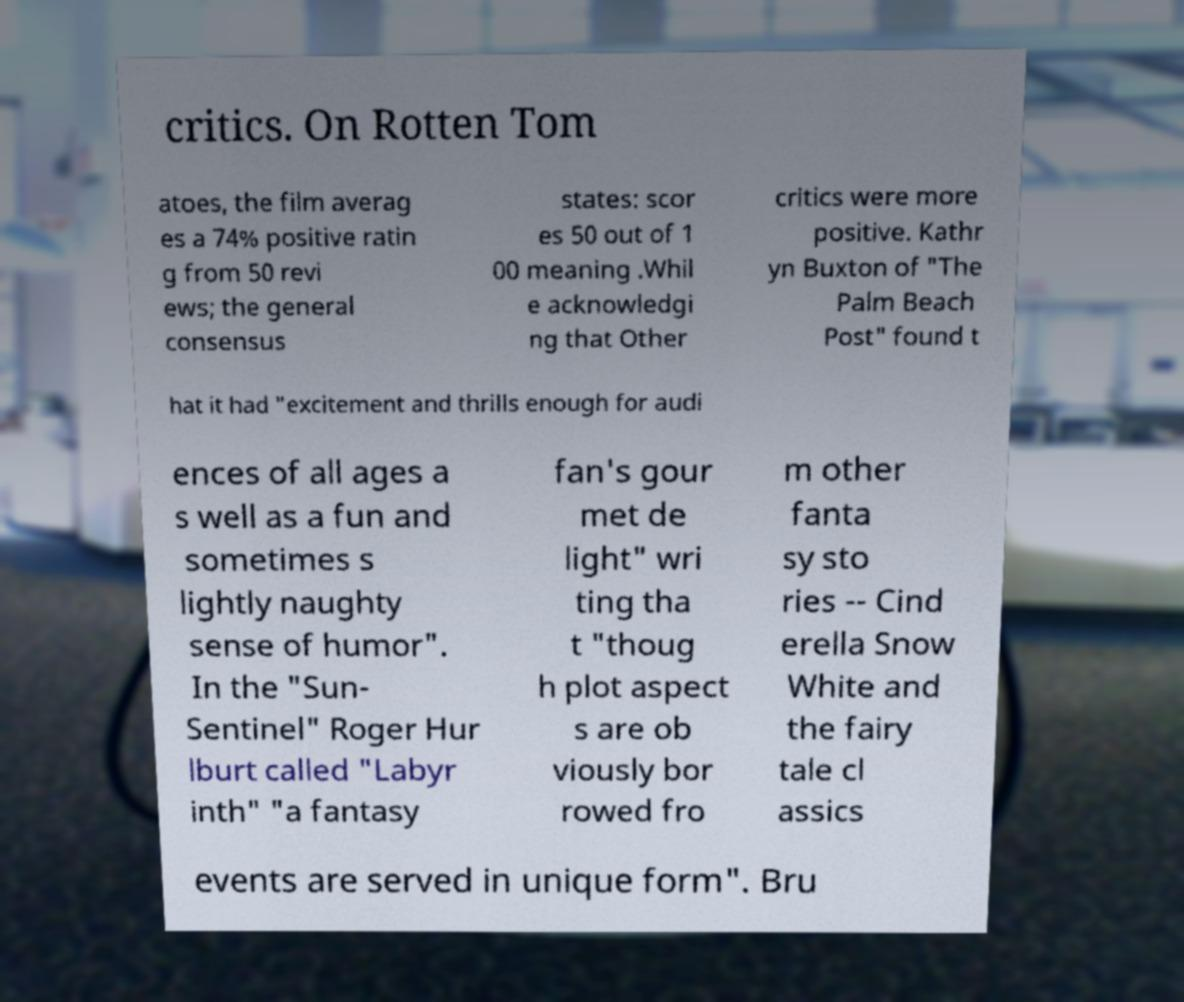There's text embedded in this image that I need extracted. Can you transcribe it verbatim? critics. On Rotten Tom atoes, the film averag es a 74% positive ratin g from 50 revi ews; the general consensus states: scor es 50 out of 1 00 meaning .Whil e acknowledgi ng that Other critics were more positive. Kathr yn Buxton of "The Palm Beach Post" found t hat it had "excitement and thrills enough for audi ences of all ages a s well as a fun and sometimes s lightly naughty sense of humor". In the "Sun- Sentinel" Roger Hur lburt called "Labyr inth" "a fantasy fan's gour met de light" wri ting tha t "thoug h plot aspect s are ob viously bor rowed fro m other fanta sy sto ries -- Cind erella Snow White and the fairy tale cl assics events are served in unique form". Bru 